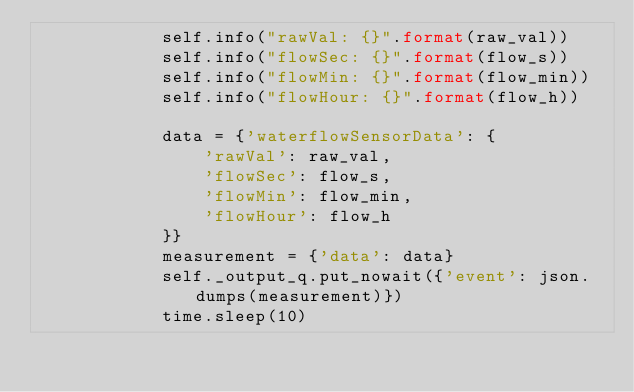Convert code to text. <code><loc_0><loc_0><loc_500><loc_500><_Python_>            self.info("rawVal: {}".format(raw_val))
            self.info("flowSec: {}".format(flow_s))
            self.info("flowMin: {}".format(flow_min))
            self.info("flowHour: {}".format(flow_h))

            data = {'waterflowSensorData': {
                'rawVal': raw_val,
                'flowSec': flow_s,
                'flowMin': flow_min,
                'flowHour': flow_h
            }}
            measurement = {'data': data}
            self._output_q.put_nowait({'event': json.dumps(measurement)})
            time.sleep(10)
</code> 